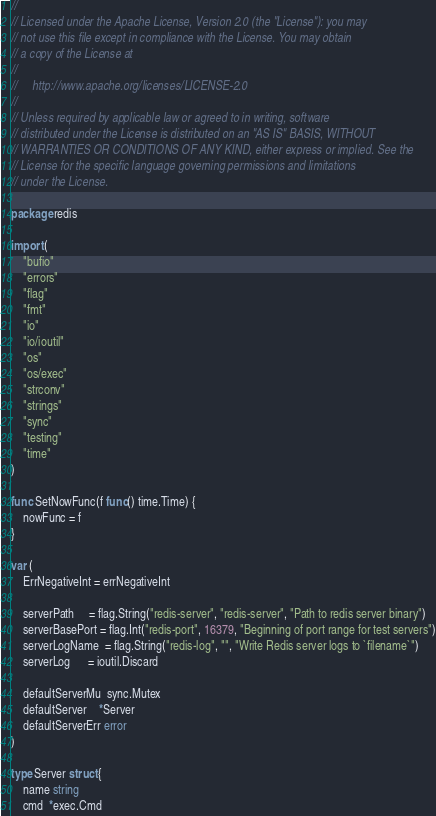Convert code to text. <code><loc_0><loc_0><loc_500><loc_500><_Go_>//
// Licensed under the Apache License, Version 2.0 (the "License"): you may
// not use this file except in compliance with the License. You may obtain
// a copy of the License at
//
//     http://www.apache.org/licenses/LICENSE-2.0
//
// Unless required by applicable law or agreed to in writing, software
// distributed under the License is distributed on an "AS IS" BASIS, WITHOUT
// WARRANTIES OR CONDITIONS OF ANY KIND, either express or implied. See the
// License for the specific language governing permissions and limitations
// under the License.

package redis

import (
	"bufio"
	"errors"
	"flag"
	"fmt"
	"io"
	"io/ioutil"
	"os"
	"os/exec"
	"strconv"
	"strings"
	"sync"
	"testing"
	"time"
)

func SetNowFunc(f func() time.Time) {
	nowFunc = f
}

var (
	ErrNegativeInt = errNegativeInt

	serverPath     = flag.String("redis-server", "redis-server", "Path to redis server binary")
	serverBasePort = flag.Int("redis-port", 16379, "Beginning of port range for test servers")
	serverLogName  = flag.String("redis-log", "", "Write Redis server logs to `filename`")
	serverLog      = ioutil.Discard

	defaultServerMu  sync.Mutex
	defaultServer    *Server
	defaultServerErr error
)

type Server struct {
	name string
	cmd  *exec.Cmd</code> 